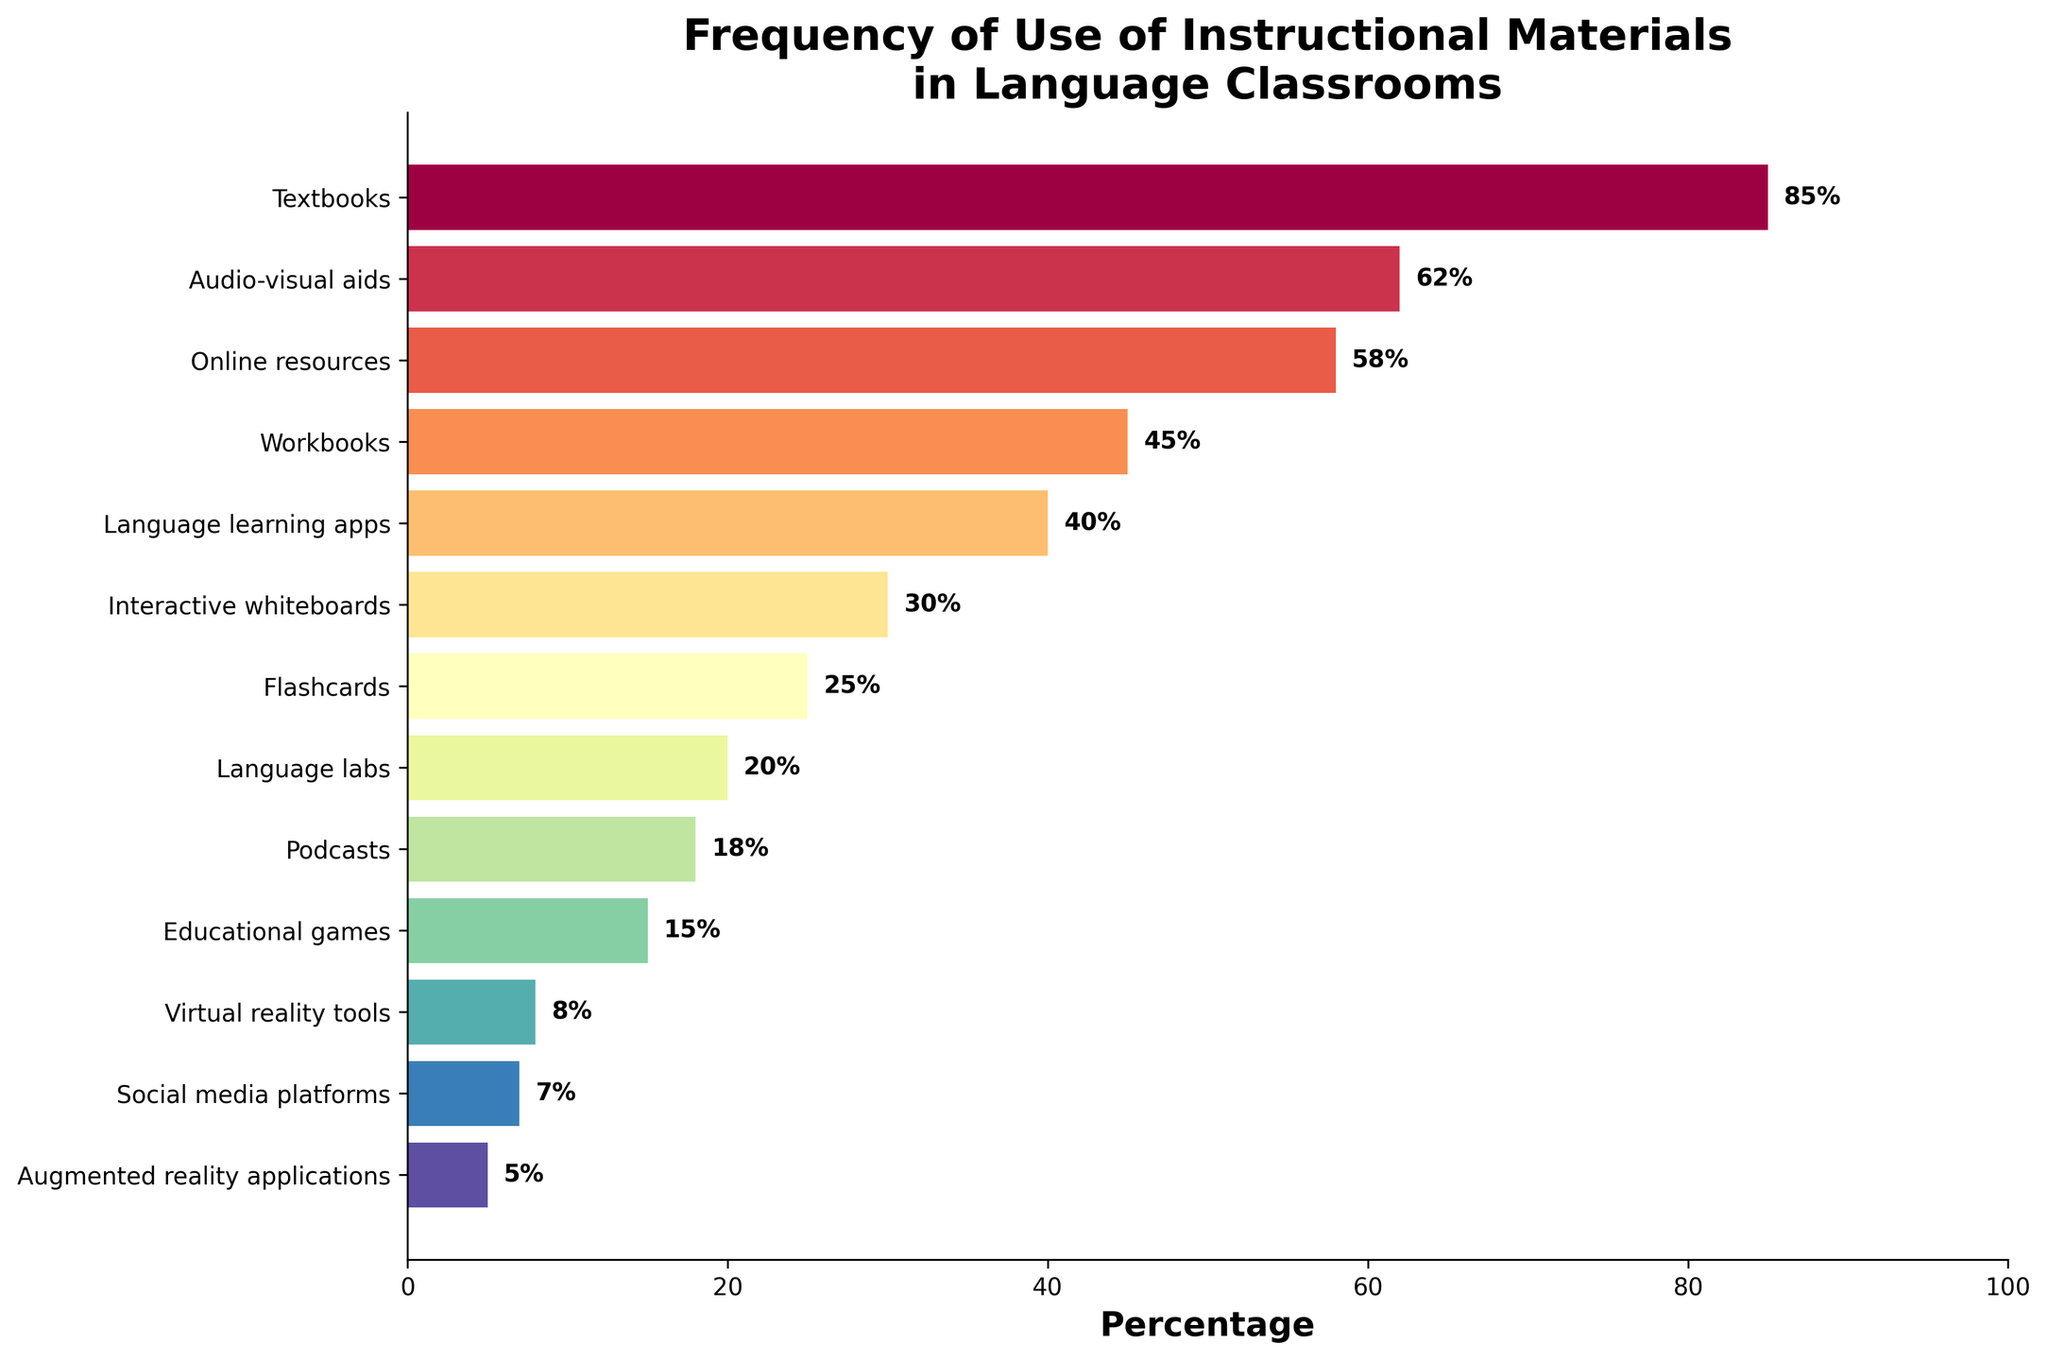Which instructional material is used the most in language classrooms? The figure shows various instructional materials and their usage percentages. Textbooks have the highest percentage at 85%.
Answer: Textbooks What is the difference in usage percentage between Audio-visual aids and Online resources? Audio-visual aids are used 62% of the time, and Online resources are used 58% of the time. The difference is 62% - 58% = 4%.
Answer: 4% Which instructional material is the least used in language classrooms? The instructional materials are ordered by usage percentage in the figure. Augmented reality applications have the lowest usage percentage at 5%.
Answer: Augmented reality applications Compare the usage of Language learning apps and Educational games. Which one is used more and by how much? Language learning apps are used 40% of the time, while Educational games are used 15% of the time. Language learning apps are used 40% - 15% = 25% more than Educational games.
Answer: Language learning apps by 25% How many instructional materials have a usage frequency of less than 20%? The figure lists the instructional materials and their percentages. Those with less than 20% usage are Language labs (20%), Podcasts (18%), Educational games (15%), Virtual reality tools (8%), Social media platforms (7%), and Augmented reality applications (5%). There are 6 materials.
Answer: 6 What is the sum of the percentages for Workbooks and Language labs? Workbooks have a percentage usage of 45% and Language labs have 20%. The sum is 45% + 20% = 65%.
Answer: 65% Which instructional material showed a usage frequency closest to 50%? The instructional material with a usage frequency closest to 50% is Online resources at 58%, as it is the nearest percentage above 50%.
Answer: Online resources How does the usage of Interactive whiteboards compare to that of Flashcards? Interactive whiteboards have a usage percentage of 30%, whereas Flashcards have a percentage of 25%. Interactive whiteboards are used 5% more often than Flashcards.
Answer: Interactive whiteboards by 5% What percentage of the combined use do Textbooks, Audio-visual aids, and Online resources contribute? Textbooks are used 85%, Audio-visual aids 62%, and Online resources 58%. Combined usage is 85% + 62% + 58% = 205%.
Answer: 205% Is the usage percentage of Podcasts greater than that of Language labs? The figure shows Podcasts have a usage percentage of 18%, whereas Language labs have 20%. Therefore, Podcasts have a lower usage percentage than Language labs.
Answer: No 